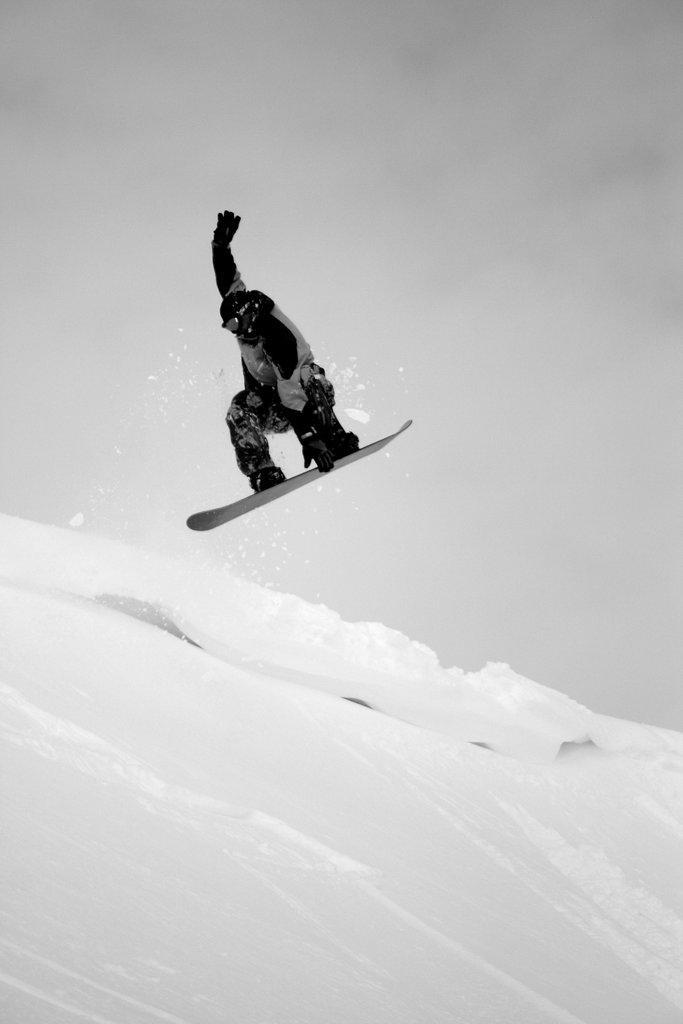Can you describe this image briefly? In the center of the image we can see a person is surfing on the snow. And we can see he is in a different costume. In the background, we can see the sky, clouds and snow. 